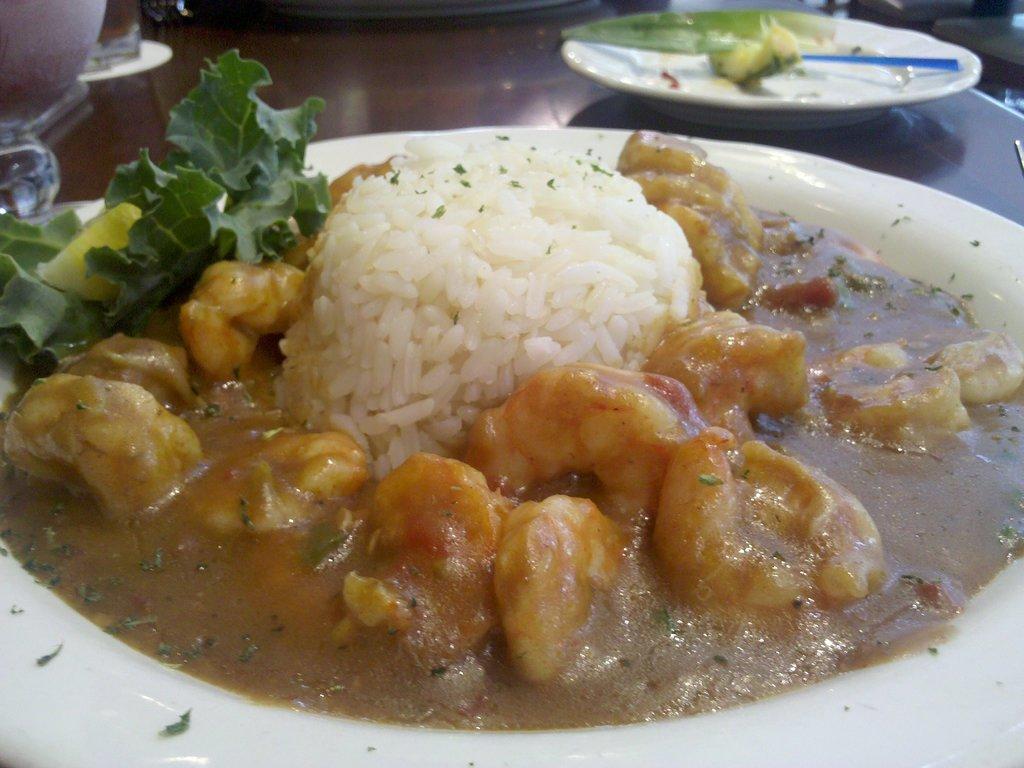How would you summarize this image in a sentence or two? In this image I can see the food items in the plates. The plates are on the brown color surface. The food is in white, green and brown color. 